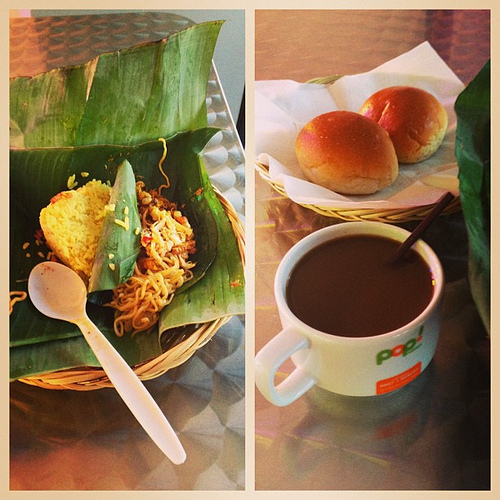Can you describe the texture of the table's surface? The table's surface appears smooth, with a metallic sheen that suggests a sleek, cool touch, much like brushed steel or aluminum. 